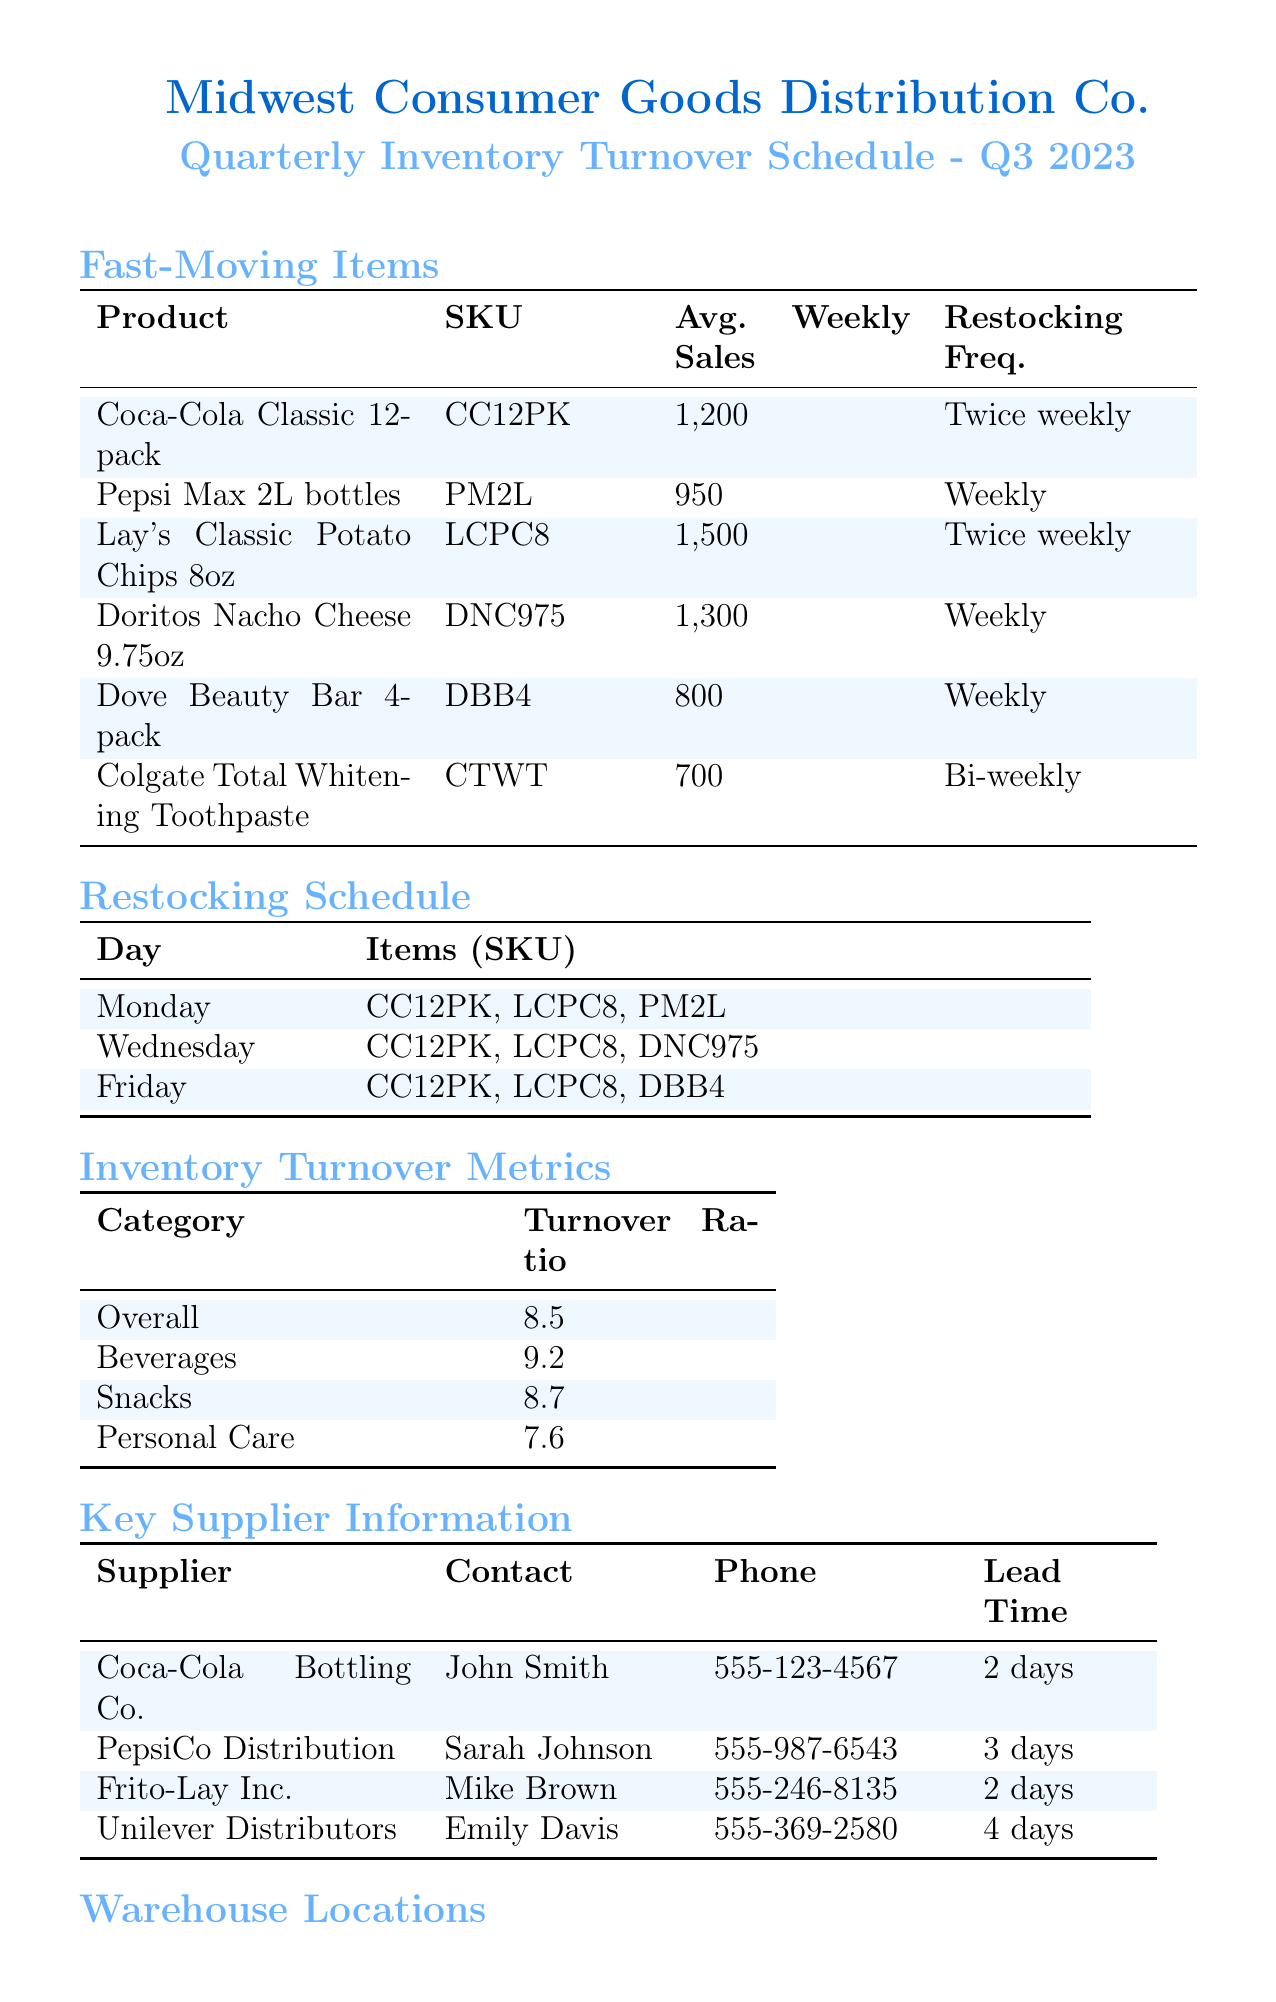What is the overall turnover ratio? The overall turnover ratio is stated in the inventory turnover metrics section, which shows the value as 8.5.
Answer: 8.5 On which day are Lay's Classic Potato Chips restocked? The restocking schedule lists the days when items are restocked, showing Monday, Wednesday, and Friday for Lay's Classic Potato Chips.
Answer: Monday, Wednesday, Friday What is the average weekly sales figure for Coca-Cola Classic 12-pack? The sales data for Coca-Cola Classic 12-pack indicates its average weekly sales figure is 1200.
Answer: 1200 How many fast-moving items are categorized under Snacks? The fast-moving items section lists two products in the Snacks category, referring to both Lay's and Doritos.
Answer: 2 Who is the contact person for PepsiCo Distribution? The supplier information section provides the contact name for PepsiCo Distribution, which is Sarah Johnson.
Answer: Sarah Johnson What is the lead time for Unilever Distributors? The lead time for Unilever Distributors is mentioned in the supplier information, specified as 4 days.
Answer: 4 days Which warehouse has a capacity of 50,000 sq ft? The warehouse locations section clearly states that the Central Warehouse has a capacity of 50,000 sq ft.
Answer: Central Warehouse Which product has the highest average weekly sales? The fast-moving items section indicates that Lay's Classic Potato Chips has the highest average weekly sales of 1500.
Answer: Lay's Classic Potato Chips What is the SKU for Doritos Nacho Cheese? The fast-moving items section lists the SKU for Doritos Nacho Cheese as DNC975.
Answer: DNC975 